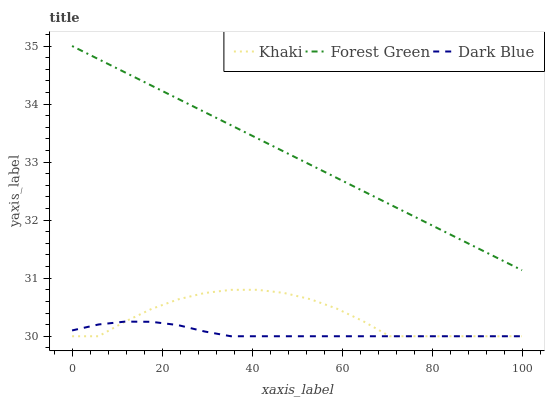Does Dark Blue have the minimum area under the curve?
Answer yes or no. Yes. Does Forest Green have the maximum area under the curve?
Answer yes or no. Yes. Does Khaki have the minimum area under the curve?
Answer yes or no. No. Does Khaki have the maximum area under the curve?
Answer yes or no. No. Is Forest Green the smoothest?
Answer yes or no. Yes. Is Khaki the roughest?
Answer yes or no. Yes. Is Khaki the smoothest?
Answer yes or no. No. Is Forest Green the roughest?
Answer yes or no. No. Does Dark Blue have the lowest value?
Answer yes or no. Yes. Does Forest Green have the lowest value?
Answer yes or no. No. Does Forest Green have the highest value?
Answer yes or no. Yes. Does Khaki have the highest value?
Answer yes or no. No. Is Dark Blue less than Forest Green?
Answer yes or no. Yes. Is Forest Green greater than Dark Blue?
Answer yes or no. Yes. Does Khaki intersect Dark Blue?
Answer yes or no. Yes. Is Khaki less than Dark Blue?
Answer yes or no. No. Is Khaki greater than Dark Blue?
Answer yes or no. No. Does Dark Blue intersect Forest Green?
Answer yes or no. No. 